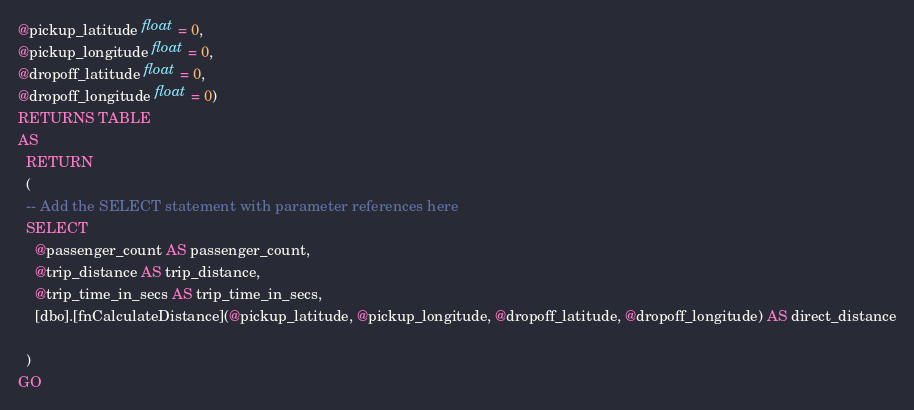<code> <loc_0><loc_0><loc_500><loc_500><_SQL_>@pickup_latitude float = 0,
@pickup_longitude float = 0,
@dropoff_latitude float = 0,
@dropoff_longitude float = 0)
RETURNS TABLE
AS
  RETURN
  (
  -- Add the SELECT statement with parameter references here
  SELECT
    @passenger_count AS passenger_count,
    @trip_distance AS trip_distance,
    @trip_time_in_secs AS trip_time_in_secs,
    [dbo].[fnCalculateDistance](@pickup_latitude, @pickup_longitude, @dropoff_latitude, @dropoff_longitude) AS direct_distance

  )
GO

</code> 